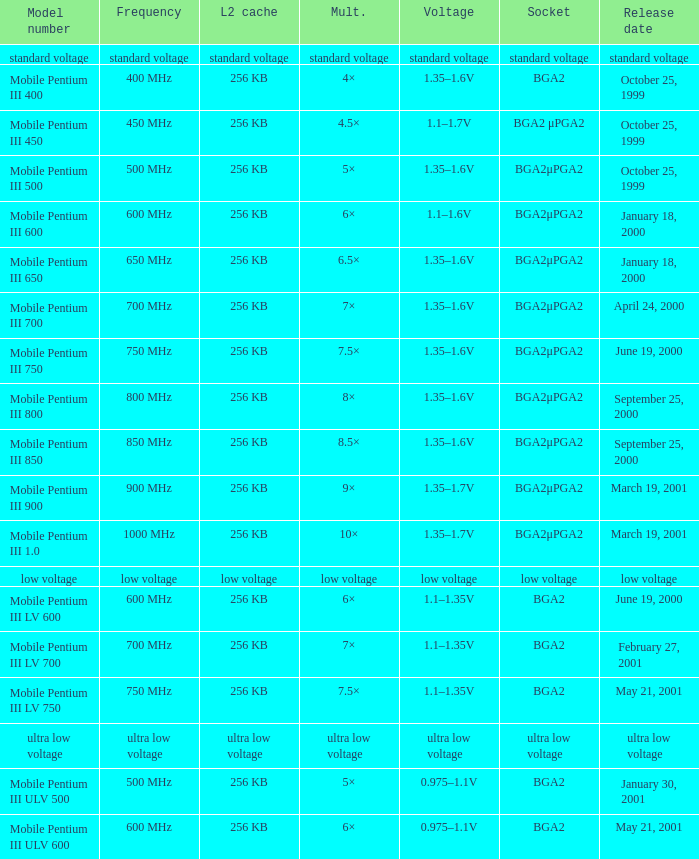What model number employs standard voltage plug? Standard voltage. 